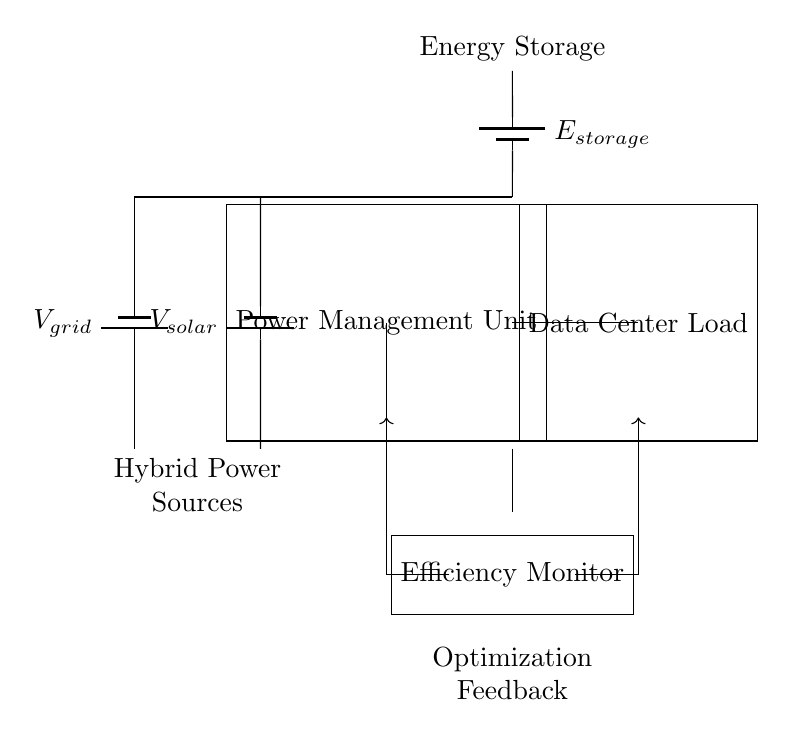What are the two power sources in this circuit? The power sources are labeled as V_grid and V_solar. Together, they indicate a hybrid system that utilizes both grid power and solar energy.
Answer: V_grid, V_solar What component manages the power in the circuit? The power management unit, depicted as a rectangle in the circuit, coordinates and optimizes the power flow from the sources to the load.
Answer: Power Management Unit What is connected to the energy storage? The circuit shows that the energy storage is connected to the power management unit and the battery source, indicating it stores energy from these sources before supplying the load.
Answer: Power Management Unit How does the efficiency monitor influence the system? The efficiency monitor provides feedback to optimize power distribution, indicated by the directed arrows showing it sends information back to the power management unit for adjustments.
Answer: Optimization feedback What load is being powered in this configuration? The load connected to the power management unit is designated as the data center, which requires a significant amount of energy to operate efficiently.
Answer: Data Center Load Which higher voltage is indicated for energy storage? The energy storage in the circuit is connected through a source labeled E_storage, indicating a specific potential for storing energy efficiently until needed.
Answer: E_storage How does the feedback influence the circuit's operation? The feedback drives adjustments in the distribution of power based on real-time efficiency data, allowing the management unit to allocate energy resources effectively, thus improving the overall energy efficiency of the system.
Answer: Optimization feedback 